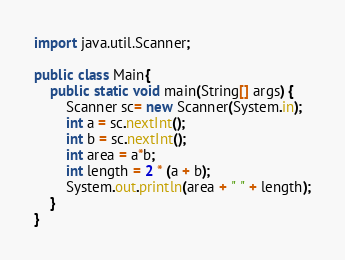<code> <loc_0><loc_0><loc_500><loc_500><_Java_>import java.util.Scanner;

public class Main{
    public static void main(String[] args) {
        Scanner sc= new Scanner(System.in);
        int a = sc.nextInt();
        int b = sc.nextInt();
        int area = a*b;
        int length = 2 * (a + b);
        System.out.println(area + " " + length);
    }
}</code> 